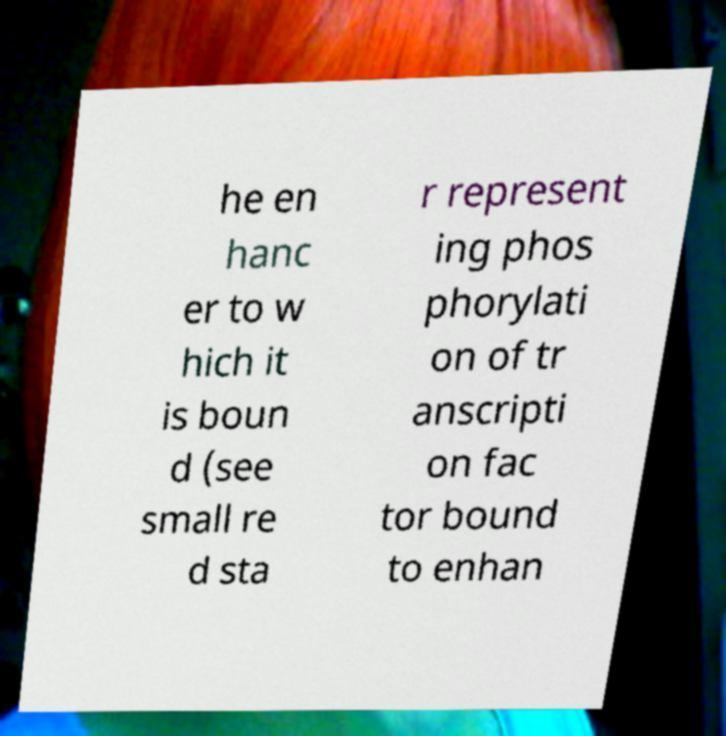What messages or text are displayed in this image? I need them in a readable, typed format. he en hanc er to w hich it is boun d (see small re d sta r represent ing phos phorylati on of tr anscripti on fac tor bound to enhan 